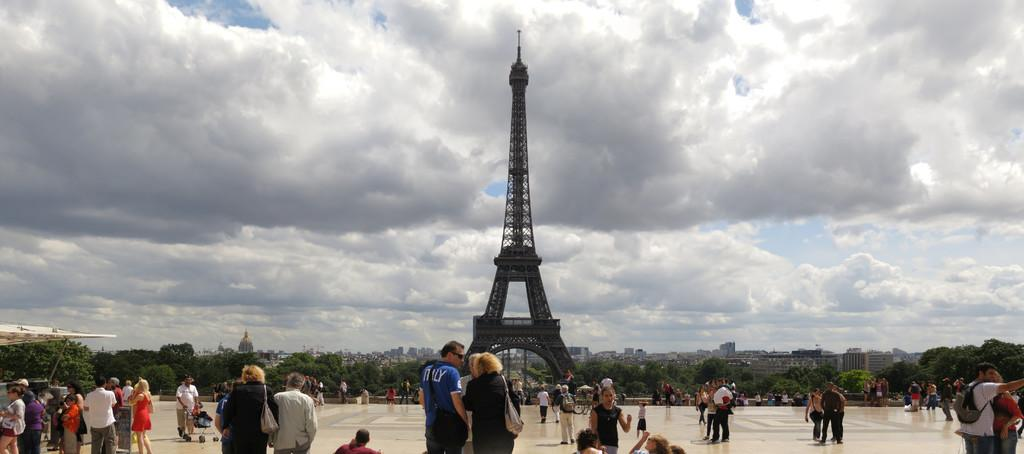What can be seen in the image? There are people standing in the image. What is visible in the background of the image? There are trees, buildings, a tower, and the sky visible in the background of the image. What type of chin can be seen on the cactus in the image? There is no cactus present in the image, so it is not possible to determine the type of chin on a cactus. 